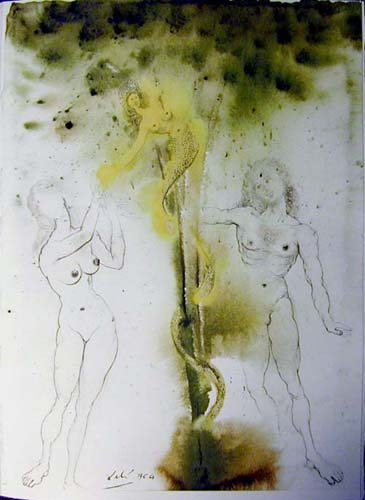Can you describe the main features of this image for me?
 The image presents a surrealistic scene, where three figures are suspended in a space filled with a wash of green and yellow hues. The figures are sketched with black lines, giving them a raw and sketch-like appearance. Two of the figures are depicted nude, adding to the surreal and dreamlike quality of the piece. One of the figures is seen holding onto a long, winding object that resembles a plant, further enhancing the surrealism of the scene. The background is speckled with black, adding depth and texture to the overall composition. The art style is distinctly surrealistic, characterized by the use of dreamlike or fantastical imagery. 